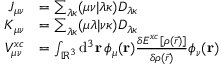<formula> <loc_0><loc_0><loc_500><loc_500>\begin{array} { r l } { J _ { \mu \nu } } & { = \sum _ { \lambda \kappa } ( \mu \nu | \lambda \kappa ) D _ { \lambda \kappa } } \\ { K _ { \mu \nu } } & { = \sum _ { \lambda \kappa } ( \mu \lambda | \nu \kappa ) D _ { \lambda \kappa } } \\ { V _ { \mu \nu } ^ { x c } } & { = \int _ { \mathbb { R } ^ { 3 } } d ^ { 3 } r \, \phi _ { \mu } ( r ) \frac { \delta E ^ { x c } [ \rho ( \vec { r } ) ] } { \delta \rho ( \vec { r } ) } \phi _ { \nu } ( r ) } \end{array}</formula> 